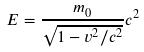Convert formula to latex. <formula><loc_0><loc_0><loc_500><loc_500>E = \frac { m _ { 0 } } { \sqrt { 1 - v ^ { 2 } / c ^ { 2 } } } c ^ { 2 }</formula> 